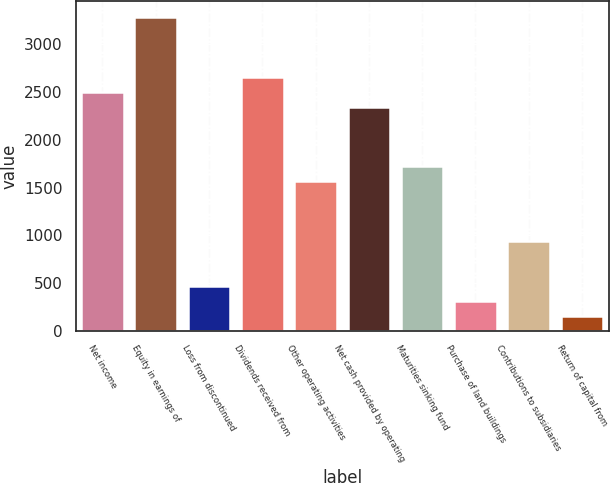Convert chart to OTSL. <chart><loc_0><loc_0><loc_500><loc_500><bar_chart><fcel>Net income<fcel>Equity in earnings of<fcel>Loss from discontinued<fcel>Dividends received from<fcel>Other operating activities<fcel>Net cash provided by operating<fcel>Maturities sinking fund<fcel>Purchase of land buildings<fcel>Contributions to subsidiaries<fcel>Return of capital from<nl><fcel>2504.4<fcel>3286.4<fcel>471.2<fcel>2660.8<fcel>1566<fcel>2348<fcel>1722.4<fcel>314.8<fcel>940.4<fcel>158.4<nl></chart> 